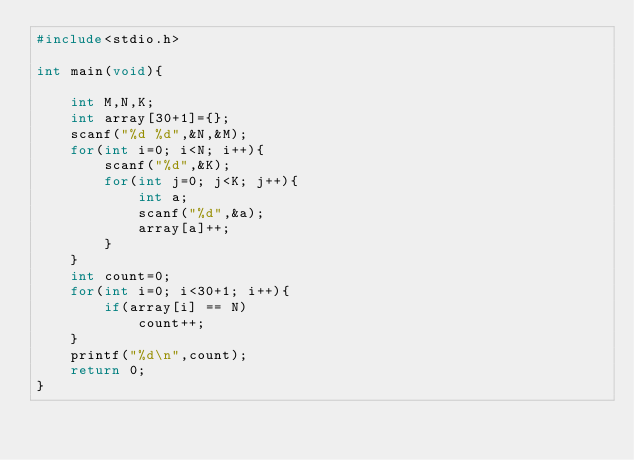<code> <loc_0><loc_0><loc_500><loc_500><_C_>#include<stdio.h>

int main(void){
    
    int M,N,K;
    int array[30+1]={};
    scanf("%d %d",&N,&M);
    for(int i=0; i<N; i++){
        scanf("%d",&K);
        for(int j=0; j<K; j++){
            int a;
            scanf("%d",&a);
            array[a]++;
        }
    }
    int count=0;
    for(int i=0; i<30+1; i++){
        if(array[i] == N)
            count++;
    }
    printf("%d\n",count);
    return 0;
}
</code> 